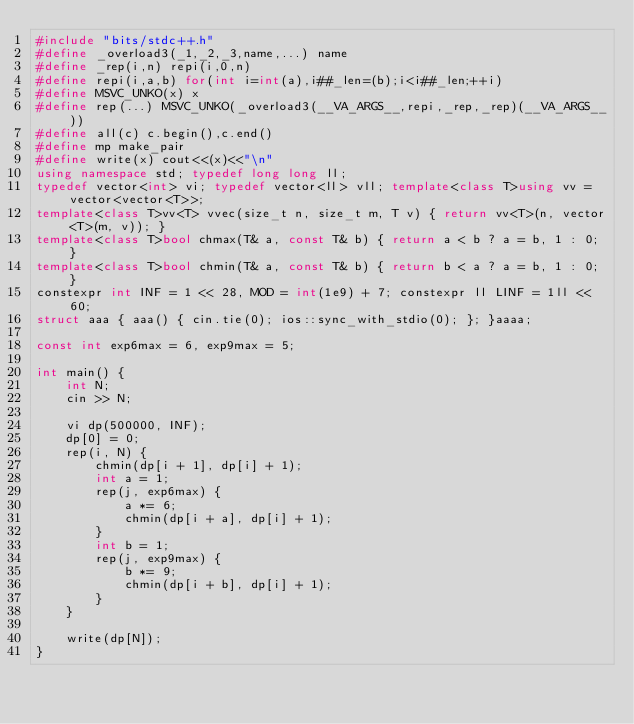<code> <loc_0><loc_0><loc_500><loc_500><_C++_>#include "bits/stdc++.h"
#define _overload3(_1,_2,_3,name,...) name
#define _rep(i,n) repi(i,0,n)
#define repi(i,a,b) for(int i=int(a),i##_len=(b);i<i##_len;++i)
#define MSVC_UNKO(x) x
#define rep(...) MSVC_UNKO(_overload3(__VA_ARGS__,repi,_rep,_rep)(__VA_ARGS__))
#define all(c) c.begin(),c.end()
#define mp make_pair
#define write(x) cout<<(x)<<"\n"
using namespace std; typedef long long ll;
typedef vector<int> vi; typedef vector<ll> vll; template<class T>using vv = vector<vector<T>>;
template<class T>vv<T> vvec(size_t n, size_t m, T v) { return vv<T>(n, vector<T>(m, v)); }
template<class T>bool chmax(T& a, const T& b) { return a < b ? a = b, 1 : 0; }
template<class T>bool chmin(T& a, const T& b) { return b < a ? a = b, 1 : 0; }
constexpr int INF = 1 << 28, MOD = int(1e9) + 7; constexpr ll LINF = 1ll << 60;
struct aaa { aaa() { cin.tie(0); ios::sync_with_stdio(0); }; }aaaa;

const int exp6max = 6, exp9max = 5;

int main() {
    int N;
    cin >> N;

    vi dp(500000, INF);
    dp[0] = 0;
    rep(i, N) {
        chmin(dp[i + 1], dp[i] + 1);
        int a = 1;
        rep(j, exp6max) {
            a *= 6;
            chmin(dp[i + a], dp[i] + 1);
        }
        int b = 1;
        rep(j, exp9max) {
            b *= 9;
            chmin(dp[i + b], dp[i] + 1);
        }
    }

    write(dp[N]);
}</code> 